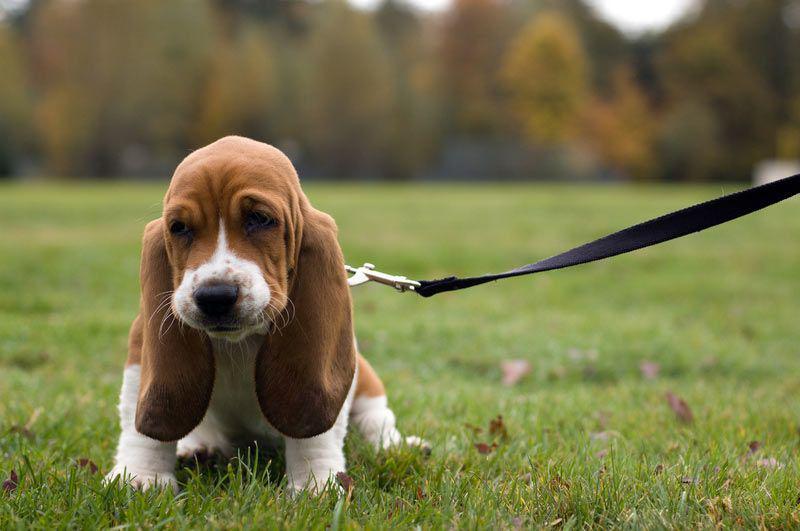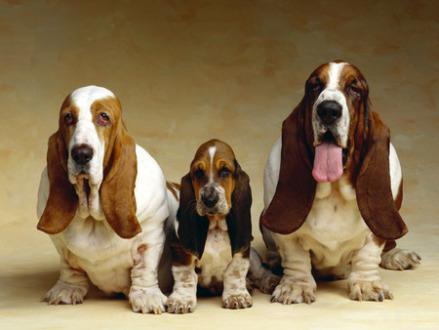The first image is the image on the left, the second image is the image on the right. Evaluate the accuracy of this statement regarding the images: "The left image shows a basset pup on green grass.". Is it true? Answer yes or no. Yes. 